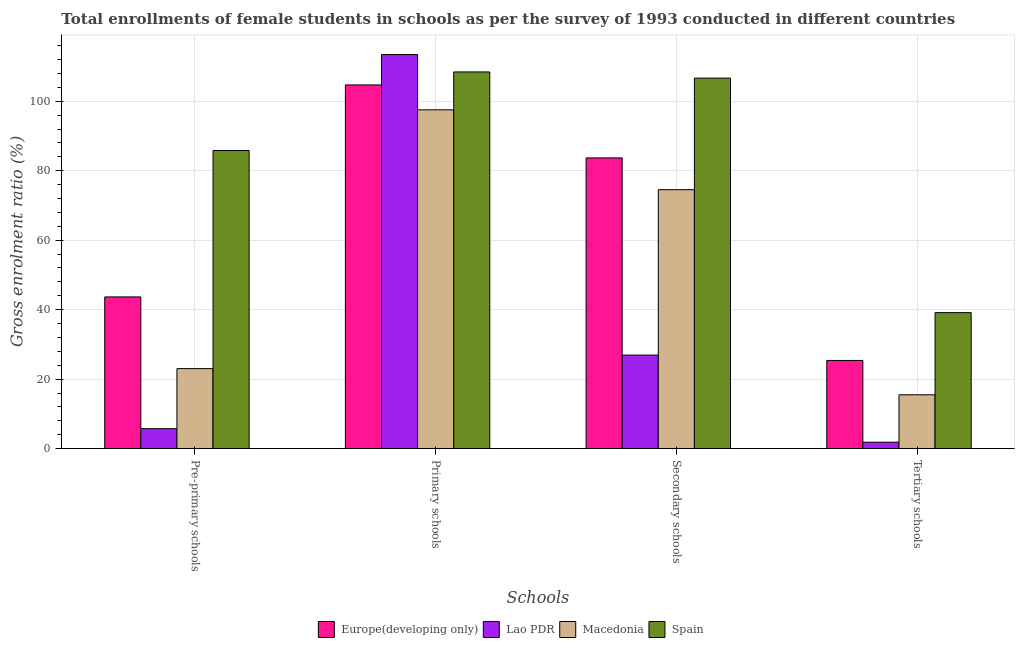Are the number of bars per tick equal to the number of legend labels?
Your answer should be very brief. Yes. How many bars are there on the 1st tick from the right?
Provide a succinct answer. 4. What is the label of the 3rd group of bars from the left?
Make the answer very short. Secondary schools. What is the gross enrolment ratio(female) in pre-primary schools in Spain?
Ensure brevity in your answer.  85.82. Across all countries, what is the maximum gross enrolment ratio(female) in tertiary schools?
Your answer should be compact. 39.15. Across all countries, what is the minimum gross enrolment ratio(female) in primary schools?
Ensure brevity in your answer.  97.52. In which country was the gross enrolment ratio(female) in primary schools maximum?
Offer a very short reply. Lao PDR. In which country was the gross enrolment ratio(female) in secondary schools minimum?
Make the answer very short. Lao PDR. What is the total gross enrolment ratio(female) in pre-primary schools in the graph?
Your answer should be compact. 158.3. What is the difference between the gross enrolment ratio(female) in secondary schools in Europe(developing only) and that in Macedonia?
Give a very brief answer. 9.15. What is the difference between the gross enrolment ratio(female) in secondary schools in Macedonia and the gross enrolment ratio(female) in primary schools in Europe(developing only)?
Offer a very short reply. -30.15. What is the average gross enrolment ratio(female) in pre-primary schools per country?
Keep it short and to the point. 39.57. What is the difference between the gross enrolment ratio(female) in primary schools and gross enrolment ratio(female) in pre-primary schools in Spain?
Give a very brief answer. 22.6. In how many countries, is the gross enrolment ratio(female) in tertiary schools greater than 28 %?
Offer a terse response. 1. What is the ratio of the gross enrolment ratio(female) in tertiary schools in Lao PDR to that in Macedonia?
Provide a short and direct response. 0.12. Is the difference between the gross enrolment ratio(female) in tertiary schools in Macedonia and Europe(developing only) greater than the difference between the gross enrolment ratio(female) in pre-primary schools in Macedonia and Europe(developing only)?
Your answer should be very brief. Yes. What is the difference between the highest and the second highest gross enrolment ratio(female) in tertiary schools?
Provide a succinct answer. 13.76. What is the difference between the highest and the lowest gross enrolment ratio(female) in primary schools?
Your answer should be very brief. 15.9. In how many countries, is the gross enrolment ratio(female) in pre-primary schools greater than the average gross enrolment ratio(female) in pre-primary schools taken over all countries?
Make the answer very short. 2. Is it the case that in every country, the sum of the gross enrolment ratio(female) in pre-primary schools and gross enrolment ratio(female) in primary schools is greater than the sum of gross enrolment ratio(female) in tertiary schools and gross enrolment ratio(female) in secondary schools?
Provide a succinct answer. Yes. What does the 2nd bar from the left in Primary schools represents?
Keep it short and to the point. Lao PDR. What does the 4th bar from the right in Primary schools represents?
Offer a very short reply. Europe(developing only). Is it the case that in every country, the sum of the gross enrolment ratio(female) in pre-primary schools and gross enrolment ratio(female) in primary schools is greater than the gross enrolment ratio(female) in secondary schools?
Offer a terse response. Yes. Are all the bars in the graph horizontal?
Provide a succinct answer. No. Does the graph contain any zero values?
Your response must be concise. No. Does the graph contain grids?
Offer a very short reply. Yes. Where does the legend appear in the graph?
Make the answer very short. Bottom center. How many legend labels are there?
Provide a short and direct response. 4. How are the legend labels stacked?
Provide a succinct answer. Horizontal. What is the title of the graph?
Make the answer very short. Total enrollments of female students in schools as per the survey of 1993 conducted in different countries. What is the label or title of the X-axis?
Offer a very short reply. Schools. What is the label or title of the Y-axis?
Keep it short and to the point. Gross enrolment ratio (%). What is the Gross enrolment ratio (%) in Europe(developing only) in Pre-primary schools?
Give a very brief answer. 43.68. What is the Gross enrolment ratio (%) in Lao PDR in Pre-primary schools?
Provide a short and direct response. 5.76. What is the Gross enrolment ratio (%) of Macedonia in Pre-primary schools?
Your answer should be very brief. 23.04. What is the Gross enrolment ratio (%) in Spain in Pre-primary schools?
Make the answer very short. 85.82. What is the Gross enrolment ratio (%) in Europe(developing only) in Primary schools?
Ensure brevity in your answer.  104.69. What is the Gross enrolment ratio (%) of Lao PDR in Primary schools?
Your answer should be very brief. 113.42. What is the Gross enrolment ratio (%) of Macedonia in Primary schools?
Provide a succinct answer. 97.52. What is the Gross enrolment ratio (%) in Spain in Primary schools?
Your response must be concise. 108.42. What is the Gross enrolment ratio (%) in Europe(developing only) in Secondary schools?
Keep it short and to the point. 83.68. What is the Gross enrolment ratio (%) of Lao PDR in Secondary schools?
Your answer should be compact. 26.94. What is the Gross enrolment ratio (%) of Macedonia in Secondary schools?
Offer a terse response. 74.53. What is the Gross enrolment ratio (%) of Spain in Secondary schools?
Provide a succinct answer. 106.65. What is the Gross enrolment ratio (%) in Europe(developing only) in Tertiary schools?
Your response must be concise. 25.39. What is the Gross enrolment ratio (%) in Lao PDR in Tertiary schools?
Your response must be concise. 1.86. What is the Gross enrolment ratio (%) of Macedonia in Tertiary schools?
Your answer should be very brief. 15.5. What is the Gross enrolment ratio (%) in Spain in Tertiary schools?
Offer a very short reply. 39.15. Across all Schools, what is the maximum Gross enrolment ratio (%) of Europe(developing only)?
Your answer should be compact. 104.69. Across all Schools, what is the maximum Gross enrolment ratio (%) of Lao PDR?
Ensure brevity in your answer.  113.42. Across all Schools, what is the maximum Gross enrolment ratio (%) of Macedonia?
Your answer should be compact. 97.52. Across all Schools, what is the maximum Gross enrolment ratio (%) of Spain?
Provide a short and direct response. 108.42. Across all Schools, what is the minimum Gross enrolment ratio (%) in Europe(developing only)?
Your response must be concise. 25.39. Across all Schools, what is the minimum Gross enrolment ratio (%) of Lao PDR?
Provide a short and direct response. 1.86. Across all Schools, what is the minimum Gross enrolment ratio (%) of Macedonia?
Provide a succinct answer. 15.5. Across all Schools, what is the minimum Gross enrolment ratio (%) in Spain?
Ensure brevity in your answer.  39.15. What is the total Gross enrolment ratio (%) of Europe(developing only) in the graph?
Your answer should be compact. 257.43. What is the total Gross enrolment ratio (%) of Lao PDR in the graph?
Keep it short and to the point. 147.98. What is the total Gross enrolment ratio (%) in Macedonia in the graph?
Your response must be concise. 210.6. What is the total Gross enrolment ratio (%) of Spain in the graph?
Provide a short and direct response. 340.04. What is the difference between the Gross enrolment ratio (%) of Europe(developing only) in Pre-primary schools and that in Primary schools?
Your answer should be very brief. -61.01. What is the difference between the Gross enrolment ratio (%) in Lao PDR in Pre-primary schools and that in Primary schools?
Provide a short and direct response. -107.66. What is the difference between the Gross enrolment ratio (%) in Macedonia in Pre-primary schools and that in Primary schools?
Your answer should be compact. -74.48. What is the difference between the Gross enrolment ratio (%) of Spain in Pre-primary schools and that in Primary schools?
Give a very brief answer. -22.6. What is the difference between the Gross enrolment ratio (%) in Europe(developing only) in Pre-primary schools and that in Secondary schools?
Your answer should be very brief. -40. What is the difference between the Gross enrolment ratio (%) in Lao PDR in Pre-primary schools and that in Secondary schools?
Provide a succinct answer. -21.18. What is the difference between the Gross enrolment ratio (%) in Macedonia in Pre-primary schools and that in Secondary schools?
Give a very brief answer. -51.49. What is the difference between the Gross enrolment ratio (%) of Spain in Pre-primary schools and that in Secondary schools?
Provide a short and direct response. -20.83. What is the difference between the Gross enrolment ratio (%) of Europe(developing only) in Pre-primary schools and that in Tertiary schools?
Provide a short and direct response. 18.28. What is the difference between the Gross enrolment ratio (%) in Lao PDR in Pre-primary schools and that in Tertiary schools?
Give a very brief answer. 3.9. What is the difference between the Gross enrolment ratio (%) in Macedonia in Pre-primary schools and that in Tertiary schools?
Provide a succinct answer. 7.54. What is the difference between the Gross enrolment ratio (%) of Spain in Pre-primary schools and that in Tertiary schools?
Your answer should be very brief. 46.67. What is the difference between the Gross enrolment ratio (%) of Europe(developing only) in Primary schools and that in Secondary schools?
Provide a short and direct response. 21.01. What is the difference between the Gross enrolment ratio (%) in Lao PDR in Primary schools and that in Secondary schools?
Make the answer very short. 86.48. What is the difference between the Gross enrolment ratio (%) of Macedonia in Primary schools and that in Secondary schools?
Provide a short and direct response. 22.99. What is the difference between the Gross enrolment ratio (%) of Spain in Primary schools and that in Secondary schools?
Ensure brevity in your answer.  1.77. What is the difference between the Gross enrolment ratio (%) in Europe(developing only) in Primary schools and that in Tertiary schools?
Ensure brevity in your answer.  79.3. What is the difference between the Gross enrolment ratio (%) of Lao PDR in Primary schools and that in Tertiary schools?
Keep it short and to the point. 111.56. What is the difference between the Gross enrolment ratio (%) in Macedonia in Primary schools and that in Tertiary schools?
Your answer should be compact. 82.02. What is the difference between the Gross enrolment ratio (%) of Spain in Primary schools and that in Tertiary schools?
Ensure brevity in your answer.  69.27. What is the difference between the Gross enrolment ratio (%) in Europe(developing only) in Secondary schools and that in Tertiary schools?
Ensure brevity in your answer.  58.29. What is the difference between the Gross enrolment ratio (%) in Lao PDR in Secondary schools and that in Tertiary schools?
Offer a very short reply. 25.08. What is the difference between the Gross enrolment ratio (%) of Macedonia in Secondary schools and that in Tertiary schools?
Provide a succinct answer. 59.03. What is the difference between the Gross enrolment ratio (%) of Spain in Secondary schools and that in Tertiary schools?
Offer a very short reply. 67.5. What is the difference between the Gross enrolment ratio (%) of Europe(developing only) in Pre-primary schools and the Gross enrolment ratio (%) of Lao PDR in Primary schools?
Keep it short and to the point. -69.74. What is the difference between the Gross enrolment ratio (%) of Europe(developing only) in Pre-primary schools and the Gross enrolment ratio (%) of Macedonia in Primary schools?
Offer a terse response. -53.85. What is the difference between the Gross enrolment ratio (%) in Europe(developing only) in Pre-primary schools and the Gross enrolment ratio (%) in Spain in Primary schools?
Make the answer very short. -64.75. What is the difference between the Gross enrolment ratio (%) of Lao PDR in Pre-primary schools and the Gross enrolment ratio (%) of Macedonia in Primary schools?
Ensure brevity in your answer.  -91.76. What is the difference between the Gross enrolment ratio (%) in Lao PDR in Pre-primary schools and the Gross enrolment ratio (%) in Spain in Primary schools?
Give a very brief answer. -102.66. What is the difference between the Gross enrolment ratio (%) in Macedonia in Pre-primary schools and the Gross enrolment ratio (%) in Spain in Primary schools?
Keep it short and to the point. -85.38. What is the difference between the Gross enrolment ratio (%) in Europe(developing only) in Pre-primary schools and the Gross enrolment ratio (%) in Lao PDR in Secondary schools?
Give a very brief answer. 16.74. What is the difference between the Gross enrolment ratio (%) of Europe(developing only) in Pre-primary schools and the Gross enrolment ratio (%) of Macedonia in Secondary schools?
Offer a terse response. -30.86. What is the difference between the Gross enrolment ratio (%) in Europe(developing only) in Pre-primary schools and the Gross enrolment ratio (%) in Spain in Secondary schools?
Provide a short and direct response. -62.97. What is the difference between the Gross enrolment ratio (%) of Lao PDR in Pre-primary schools and the Gross enrolment ratio (%) of Macedonia in Secondary schools?
Your response must be concise. -68.77. What is the difference between the Gross enrolment ratio (%) of Lao PDR in Pre-primary schools and the Gross enrolment ratio (%) of Spain in Secondary schools?
Offer a very short reply. -100.89. What is the difference between the Gross enrolment ratio (%) in Macedonia in Pre-primary schools and the Gross enrolment ratio (%) in Spain in Secondary schools?
Offer a terse response. -83.61. What is the difference between the Gross enrolment ratio (%) in Europe(developing only) in Pre-primary schools and the Gross enrolment ratio (%) in Lao PDR in Tertiary schools?
Offer a very short reply. 41.81. What is the difference between the Gross enrolment ratio (%) in Europe(developing only) in Pre-primary schools and the Gross enrolment ratio (%) in Macedonia in Tertiary schools?
Ensure brevity in your answer.  28.17. What is the difference between the Gross enrolment ratio (%) of Europe(developing only) in Pre-primary schools and the Gross enrolment ratio (%) of Spain in Tertiary schools?
Your answer should be very brief. 4.52. What is the difference between the Gross enrolment ratio (%) of Lao PDR in Pre-primary schools and the Gross enrolment ratio (%) of Macedonia in Tertiary schools?
Your response must be concise. -9.74. What is the difference between the Gross enrolment ratio (%) in Lao PDR in Pre-primary schools and the Gross enrolment ratio (%) in Spain in Tertiary schools?
Keep it short and to the point. -33.39. What is the difference between the Gross enrolment ratio (%) of Macedonia in Pre-primary schools and the Gross enrolment ratio (%) of Spain in Tertiary schools?
Keep it short and to the point. -16.11. What is the difference between the Gross enrolment ratio (%) of Europe(developing only) in Primary schools and the Gross enrolment ratio (%) of Lao PDR in Secondary schools?
Your answer should be very brief. 77.75. What is the difference between the Gross enrolment ratio (%) of Europe(developing only) in Primary schools and the Gross enrolment ratio (%) of Macedonia in Secondary schools?
Give a very brief answer. 30.15. What is the difference between the Gross enrolment ratio (%) of Europe(developing only) in Primary schools and the Gross enrolment ratio (%) of Spain in Secondary schools?
Provide a short and direct response. -1.96. What is the difference between the Gross enrolment ratio (%) of Lao PDR in Primary schools and the Gross enrolment ratio (%) of Macedonia in Secondary schools?
Ensure brevity in your answer.  38.89. What is the difference between the Gross enrolment ratio (%) of Lao PDR in Primary schools and the Gross enrolment ratio (%) of Spain in Secondary schools?
Make the answer very short. 6.77. What is the difference between the Gross enrolment ratio (%) of Macedonia in Primary schools and the Gross enrolment ratio (%) of Spain in Secondary schools?
Ensure brevity in your answer.  -9.13. What is the difference between the Gross enrolment ratio (%) of Europe(developing only) in Primary schools and the Gross enrolment ratio (%) of Lao PDR in Tertiary schools?
Make the answer very short. 102.83. What is the difference between the Gross enrolment ratio (%) of Europe(developing only) in Primary schools and the Gross enrolment ratio (%) of Macedonia in Tertiary schools?
Ensure brevity in your answer.  89.18. What is the difference between the Gross enrolment ratio (%) in Europe(developing only) in Primary schools and the Gross enrolment ratio (%) in Spain in Tertiary schools?
Offer a very short reply. 65.53. What is the difference between the Gross enrolment ratio (%) of Lao PDR in Primary schools and the Gross enrolment ratio (%) of Macedonia in Tertiary schools?
Make the answer very short. 97.92. What is the difference between the Gross enrolment ratio (%) of Lao PDR in Primary schools and the Gross enrolment ratio (%) of Spain in Tertiary schools?
Provide a succinct answer. 74.27. What is the difference between the Gross enrolment ratio (%) of Macedonia in Primary schools and the Gross enrolment ratio (%) of Spain in Tertiary schools?
Ensure brevity in your answer.  58.37. What is the difference between the Gross enrolment ratio (%) in Europe(developing only) in Secondary schools and the Gross enrolment ratio (%) in Lao PDR in Tertiary schools?
Make the answer very short. 81.82. What is the difference between the Gross enrolment ratio (%) in Europe(developing only) in Secondary schools and the Gross enrolment ratio (%) in Macedonia in Tertiary schools?
Your answer should be very brief. 68.18. What is the difference between the Gross enrolment ratio (%) of Europe(developing only) in Secondary schools and the Gross enrolment ratio (%) of Spain in Tertiary schools?
Provide a succinct answer. 44.53. What is the difference between the Gross enrolment ratio (%) of Lao PDR in Secondary schools and the Gross enrolment ratio (%) of Macedonia in Tertiary schools?
Give a very brief answer. 11.43. What is the difference between the Gross enrolment ratio (%) in Lao PDR in Secondary schools and the Gross enrolment ratio (%) in Spain in Tertiary schools?
Ensure brevity in your answer.  -12.22. What is the difference between the Gross enrolment ratio (%) of Macedonia in Secondary schools and the Gross enrolment ratio (%) of Spain in Tertiary schools?
Provide a short and direct response. 35.38. What is the average Gross enrolment ratio (%) of Europe(developing only) per Schools?
Ensure brevity in your answer.  64.36. What is the average Gross enrolment ratio (%) in Lao PDR per Schools?
Make the answer very short. 36.99. What is the average Gross enrolment ratio (%) of Macedonia per Schools?
Your answer should be compact. 52.65. What is the average Gross enrolment ratio (%) of Spain per Schools?
Provide a short and direct response. 85.01. What is the difference between the Gross enrolment ratio (%) in Europe(developing only) and Gross enrolment ratio (%) in Lao PDR in Pre-primary schools?
Make the answer very short. 37.92. What is the difference between the Gross enrolment ratio (%) of Europe(developing only) and Gross enrolment ratio (%) of Macedonia in Pre-primary schools?
Your response must be concise. 20.63. What is the difference between the Gross enrolment ratio (%) in Europe(developing only) and Gross enrolment ratio (%) in Spain in Pre-primary schools?
Give a very brief answer. -42.14. What is the difference between the Gross enrolment ratio (%) of Lao PDR and Gross enrolment ratio (%) of Macedonia in Pre-primary schools?
Your response must be concise. -17.28. What is the difference between the Gross enrolment ratio (%) in Lao PDR and Gross enrolment ratio (%) in Spain in Pre-primary schools?
Your response must be concise. -80.06. What is the difference between the Gross enrolment ratio (%) of Macedonia and Gross enrolment ratio (%) of Spain in Pre-primary schools?
Your answer should be very brief. -62.78. What is the difference between the Gross enrolment ratio (%) of Europe(developing only) and Gross enrolment ratio (%) of Lao PDR in Primary schools?
Your response must be concise. -8.73. What is the difference between the Gross enrolment ratio (%) in Europe(developing only) and Gross enrolment ratio (%) in Macedonia in Primary schools?
Give a very brief answer. 7.17. What is the difference between the Gross enrolment ratio (%) in Europe(developing only) and Gross enrolment ratio (%) in Spain in Primary schools?
Provide a succinct answer. -3.74. What is the difference between the Gross enrolment ratio (%) of Lao PDR and Gross enrolment ratio (%) of Macedonia in Primary schools?
Give a very brief answer. 15.9. What is the difference between the Gross enrolment ratio (%) of Lao PDR and Gross enrolment ratio (%) of Spain in Primary schools?
Your answer should be compact. 5. What is the difference between the Gross enrolment ratio (%) in Macedonia and Gross enrolment ratio (%) in Spain in Primary schools?
Your answer should be compact. -10.9. What is the difference between the Gross enrolment ratio (%) in Europe(developing only) and Gross enrolment ratio (%) in Lao PDR in Secondary schools?
Your response must be concise. 56.74. What is the difference between the Gross enrolment ratio (%) of Europe(developing only) and Gross enrolment ratio (%) of Macedonia in Secondary schools?
Your response must be concise. 9.15. What is the difference between the Gross enrolment ratio (%) of Europe(developing only) and Gross enrolment ratio (%) of Spain in Secondary schools?
Give a very brief answer. -22.97. What is the difference between the Gross enrolment ratio (%) in Lao PDR and Gross enrolment ratio (%) in Macedonia in Secondary schools?
Your response must be concise. -47.6. What is the difference between the Gross enrolment ratio (%) in Lao PDR and Gross enrolment ratio (%) in Spain in Secondary schools?
Your answer should be compact. -79.71. What is the difference between the Gross enrolment ratio (%) in Macedonia and Gross enrolment ratio (%) in Spain in Secondary schools?
Keep it short and to the point. -32.12. What is the difference between the Gross enrolment ratio (%) of Europe(developing only) and Gross enrolment ratio (%) of Lao PDR in Tertiary schools?
Make the answer very short. 23.53. What is the difference between the Gross enrolment ratio (%) of Europe(developing only) and Gross enrolment ratio (%) of Macedonia in Tertiary schools?
Make the answer very short. 9.89. What is the difference between the Gross enrolment ratio (%) in Europe(developing only) and Gross enrolment ratio (%) in Spain in Tertiary schools?
Make the answer very short. -13.76. What is the difference between the Gross enrolment ratio (%) of Lao PDR and Gross enrolment ratio (%) of Macedonia in Tertiary schools?
Offer a very short reply. -13.64. What is the difference between the Gross enrolment ratio (%) of Lao PDR and Gross enrolment ratio (%) of Spain in Tertiary schools?
Your answer should be very brief. -37.29. What is the difference between the Gross enrolment ratio (%) in Macedonia and Gross enrolment ratio (%) in Spain in Tertiary schools?
Offer a terse response. -23.65. What is the ratio of the Gross enrolment ratio (%) in Europe(developing only) in Pre-primary schools to that in Primary schools?
Your answer should be compact. 0.42. What is the ratio of the Gross enrolment ratio (%) in Lao PDR in Pre-primary schools to that in Primary schools?
Make the answer very short. 0.05. What is the ratio of the Gross enrolment ratio (%) in Macedonia in Pre-primary schools to that in Primary schools?
Provide a succinct answer. 0.24. What is the ratio of the Gross enrolment ratio (%) in Spain in Pre-primary schools to that in Primary schools?
Your response must be concise. 0.79. What is the ratio of the Gross enrolment ratio (%) in Europe(developing only) in Pre-primary schools to that in Secondary schools?
Make the answer very short. 0.52. What is the ratio of the Gross enrolment ratio (%) of Lao PDR in Pre-primary schools to that in Secondary schools?
Your answer should be compact. 0.21. What is the ratio of the Gross enrolment ratio (%) of Macedonia in Pre-primary schools to that in Secondary schools?
Your answer should be compact. 0.31. What is the ratio of the Gross enrolment ratio (%) of Spain in Pre-primary schools to that in Secondary schools?
Ensure brevity in your answer.  0.8. What is the ratio of the Gross enrolment ratio (%) of Europe(developing only) in Pre-primary schools to that in Tertiary schools?
Make the answer very short. 1.72. What is the ratio of the Gross enrolment ratio (%) in Lao PDR in Pre-primary schools to that in Tertiary schools?
Your response must be concise. 3.09. What is the ratio of the Gross enrolment ratio (%) in Macedonia in Pre-primary schools to that in Tertiary schools?
Offer a terse response. 1.49. What is the ratio of the Gross enrolment ratio (%) in Spain in Pre-primary schools to that in Tertiary schools?
Make the answer very short. 2.19. What is the ratio of the Gross enrolment ratio (%) of Europe(developing only) in Primary schools to that in Secondary schools?
Your answer should be compact. 1.25. What is the ratio of the Gross enrolment ratio (%) of Lao PDR in Primary schools to that in Secondary schools?
Provide a succinct answer. 4.21. What is the ratio of the Gross enrolment ratio (%) of Macedonia in Primary schools to that in Secondary schools?
Offer a terse response. 1.31. What is the ratio of the Gross enrolment ratio (%) of Spain in Primary schools to that in Secondary schools?
Your answer should be compact. 1.02. What is the ratio of the Gross enrolment ratio (%) in Europe(developing only) in Primary schools to that in Tertiary schools?
Your response must be concise. 4.12. What is the ratio of the Gross enrolment ratio (%) of Lao PDR in Primary schools to that in Tertiary schools?
Offer a terse response. 60.93. What is the ratio of the Gross enrolment ratio (%) in Macedonia in Primary schools to that in Tertiary schools?
Give a very brief answer. 6.29. What is the ratio of the Gross enrolment ratio (%) in Spain in Primary schools to that in Tertiary schools?
Your response must be concise. 2.77. What is the ratio of the Gross enrolment ratio (%) of Europe(developing only) in Secondary schools to that in Tertiary schools?
Your answer should be very brief. 3.3. What is the ratio of the Gross enrolment ratio (%) of Lao PDR in Secondary schools to that in Tertiary schools?
Ensure brevity in your answer.  14.47. What is the ratio of the Gross enrolment ratio (%) in Macedonia in Secondary schools to that in Tertiary schools?
Keep it short and to the point. 4.81. What is the ratio of the Gross enrolment ratio (%) in Spain in Secondary schools to that in Tertiary schools?
Ensure brevity in your answer.  2.72. What is the difference between the highest and the second highest Gross enrolment ratio (%) of Europe(developing only)?
Provide a succinct answer. 21.01. What is the difference between the highest and the second highest Gross enrolment ratio (%) of Lao PDR?
Your answer should be very brief. 86.48. What is the difference between the highest and the second highest Gross enrolment ratio (%) in Macedonia?
Make the answer very short. 22.99. What is the difference between the highest and the second highest Gross enrolment ratio (%) of Spain?
Offer a terse response. 1.77. What is the difference between the highest and the lowest Gross enrolment ratio (%) in Europe(developing only)?
Ensure brevity in your answer.  79.3. What is the difference between the highest and the lowest Gross enrolment ratio (%) of Lao PDR?
Your response must be concise. 111.56. What is the difference between the highest and the lowest Gross enrolment ratio (%) in Macedonia?
Your answer should be very brief. 82.02. What is the difference between the highest and the lowest Gross enrolment ratio (%) of Spain?
Offer a very short reply. 69.27. 